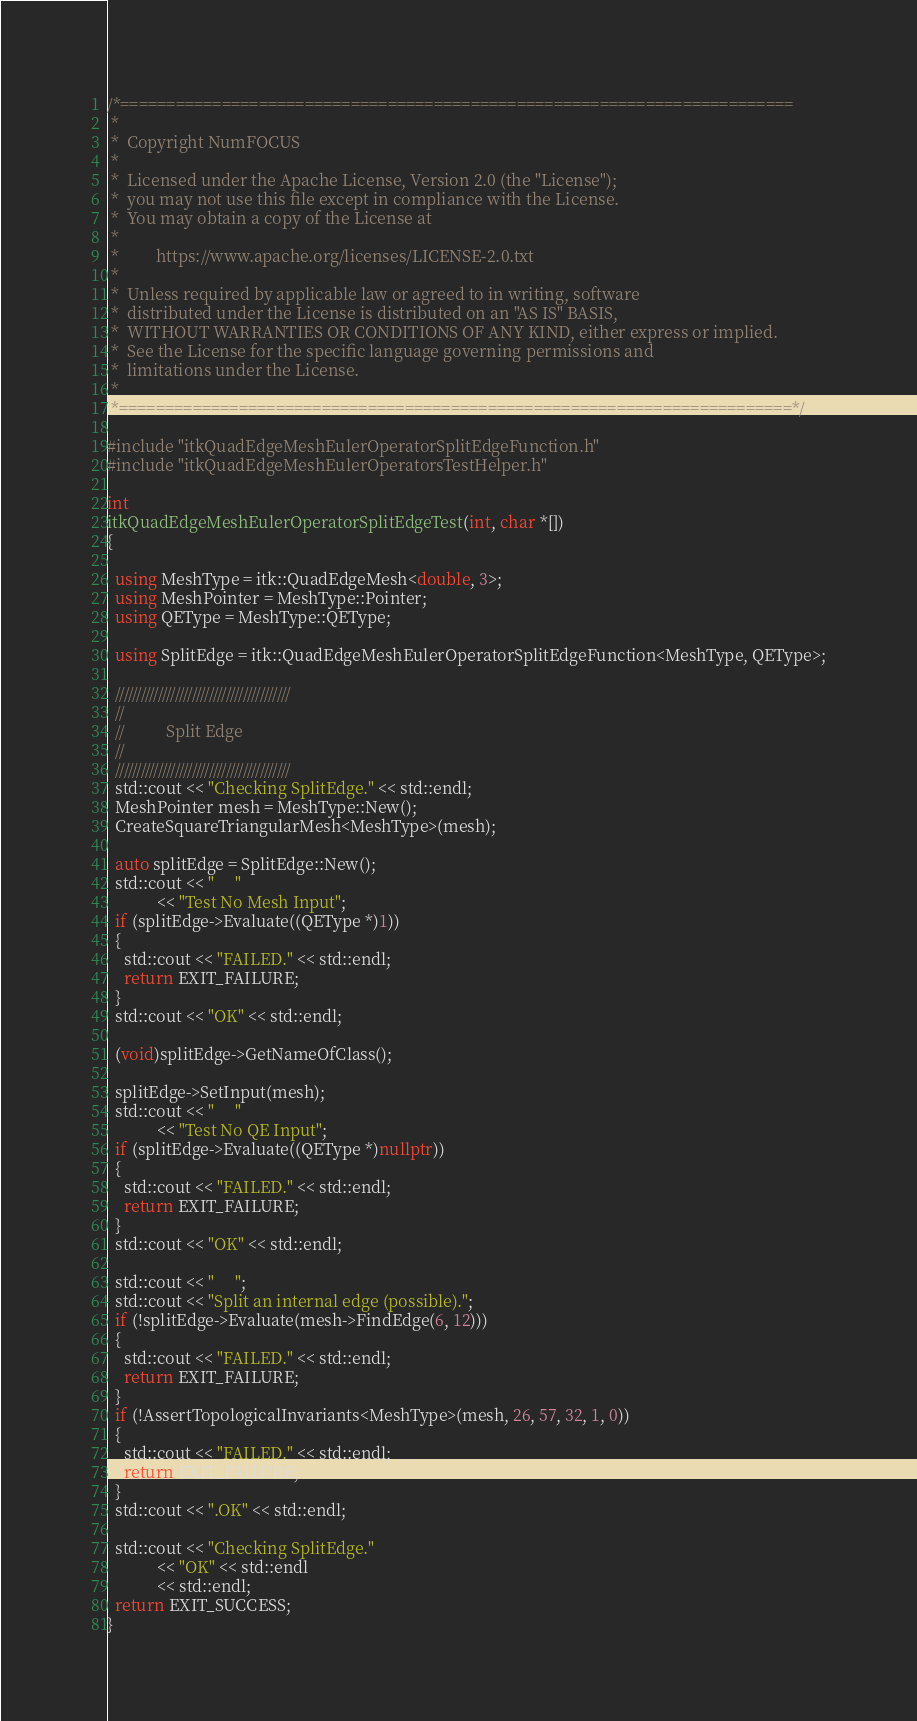Convert code to text. <code><loc_0><loc_0><loc_500><loc_500><_C++_>/*=========================================================================
 *
 *  Copyright NumFOCUS
 *
 *  Licensed under the Apache License, Version 2.0 (the "License");
 *  you may not use this file except in compliance with the License.
 *  You may obtain a copy of the License at
 *
 *         https://www.apache.org/licenses/LICENSE-2.0.txt
 *
 *  Unless required by applicable law or agreed to in writing, software
 *  distributed under the License is distributed on an "AS IS" BASIS,
 *  WITHOUT WARRANTIES OR CONDITIONS OF ANY KIND, either express or implied.
 *  See the License for the specific language governing permissions and
 *  limitations under the License.
 *
 *=========================================================================*/

#include "itkQuadEdgeMeshEulerOperatorSplitEdgeFunction.h"
#include "itkQuadEdgeMeshEulerOperatorsTestHelper.h"

int
itkQuadEdgeMeshEulerOperatorSplitEdgeTest(int, char *[])
{

  using MeshType = itk::QuadEdgeMesh<double, 3>;
  using MeshPointer = MeshType::Pointer;
  using QEType = MeshType::QEType;

  using SplitEdge = itk::QuadEdgeMeshEulerOperatorSplitEdgeFunction<MeshType, QEType>;

  /////////////////////////////////////////
  //
  //          Split Edge
  //
  /////////////////////////////////////////
  std::cout << "Checking SplitEdge." << std::endl;
  MeshPointer mesh = MeshType::New();
  CreateSquareTriangularMesh<MeshType>(mesh);

  auto splitEdge = SplitEdge::New();
  std::cout << "     "
            << "Test No Mesh Input";
  if (splitEdge->Evaluate((QEType *)1))
  {
    std::cout << "FAILED." << std::endl;
    return EXIT_FAILURE;
  }
  std::cout << "OK" << std::endl;

  (void)splitEdge->GetNameOfClass();

  splitEdge->SetInput(mesh);
  std::cout << "     "
            << "Test No QE Input";
  if (splitEdge->Evaluate((QEType *)nullptr))
  {
    std::cout << "FAILED." << std::endl;
    return EXIT_FAILURE;
  }
  std::cout << "OK" << std::endl;

  std::cout << "     ";
  std::cout << "Split an internal edge (possible).";
  if (!splitEdge->Evaluate(mesh->FindEdge(6, 12)))
  {
    std::cout << "FAILED." << std::endl;
    return EXIT_FAILURE;
  }
  if (!AssertTopologicalInvariants<MeshType>(mesh, 26, 57, 32, 1, 0))
  {
    std::cout << "FAILED." << std::endl;
    return EXIT_FAILURE;
  }
  std::cout << ".OK" << std::endl;

  std::cout << "Checking SplitEdge."
            << "OK" << std::endl
            << std::endl;
  return EXIT_SUCCESS;
}
</code> 